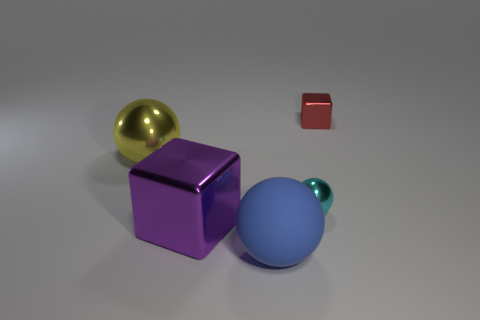There is a small thing that is the same shape as the big purple object; what color is it?
Your answer should be very brief. Red. The big object that is both behind the large rubber thing and in front of the cyan metal thing has what shape?
Ensure brevity in your answer.  Cube. The yellow metallic thing that is the same shape as the big rubber thing is what size?
Offer a terse response. Large. Are there any tiny metal balls that are in front of the sphere that is to the right of the large blue thing?
Make the answer very short. No. Is the big matte sphere the same color as the big metallic cube?
Your answer should be compact. No. Is the number of large cubes that are in front of the tiny cyan metallic thing greater than the number of purple metallic cubes that are to the left of the yellow object?
Offer a terse response. Yes. Does the sphere to the left of the big matte sphere have the same size as the cube that is to the right of the big block?
Your response must be concise. No. What color is the big ball that is made of the same material as the purple object?
Keep it short and to the point. Yellow. Are the large blue sphere and the block that is left of the cyan metallic sphere made of the same material?
Your answer should be very brief. No. What size is the purple block that is the same material as the cyan object?
Offer a very short reply. Large. 